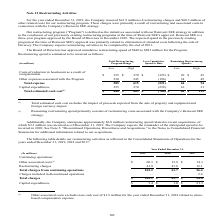From Sealed Air Corporation's financial document, How much restructuring charges and other related costs for the restructuring program was incurred for the year ended December 31, 2019 respectively? The document shows two values: $41.9 million and $60.3 million. From the document: "year ended December 31, 2019, the Company incurred $41.9 million of restructuring charges and $60.3 million of other related costs for our restructuri..." Also, What is the High Total estimated cash cost of Total Restructuring program range? According to the financial document, $ 885 (in millions). The relevant text states: "Total estimated cash cost (1) $ 840 $ 885 $ (760) $ 80 $ 125..." Also, Who approved the restructuring spend of $840 to $885 million?  The Board of Directors. The document states: "Reinvent SEE is a three-year program approved by the Board of Directors in December 2018. The expected spend in the previously existing program at the..." Also, can you calculate: Excluding the restructuring spend related to recent acquisitions, what is the low Total estimated cash cost? Based on the calculation: 840-2.3, the result is 837.7 (in millions). This is based on the information: "Total estimated cash cost (1) $ 840 $ 885 $ (760) $ 80 $ 125 g spend related to recent acquisitions, of which $2.3 million was incurred as of December 31, 2019. The Company expects the remainder of th..." The key data points involved are: 2.3, 840. Also, can you calculate: What is the Total expense expressed as a percentage of Total estimated cash cost for the low estimate? Based on the calculation: 585/840, the result is 69.64 (percentage). This is based on the information: "Total expense 585 615 (521) 64 94 Total estimated cash cost (1) $ 840 $ 885 $ (760) $ 80 $ 125..." The key data points involved are: 585, 840. Also, can you calculate: For High Total Restructuring program range, what is the Total Capital expenditure expressed as a percentage of total estimated cash cost? Based on the calculation: 270/885, the result is 30.51 (percentage). This is based on the information: "Total estimated cash cost (1) $ 840 $ 885 $ (760) $ 80 $ 125 Capital expenditures 255 270 (239) 16 31..." The key data points involved are: 270, 885. 